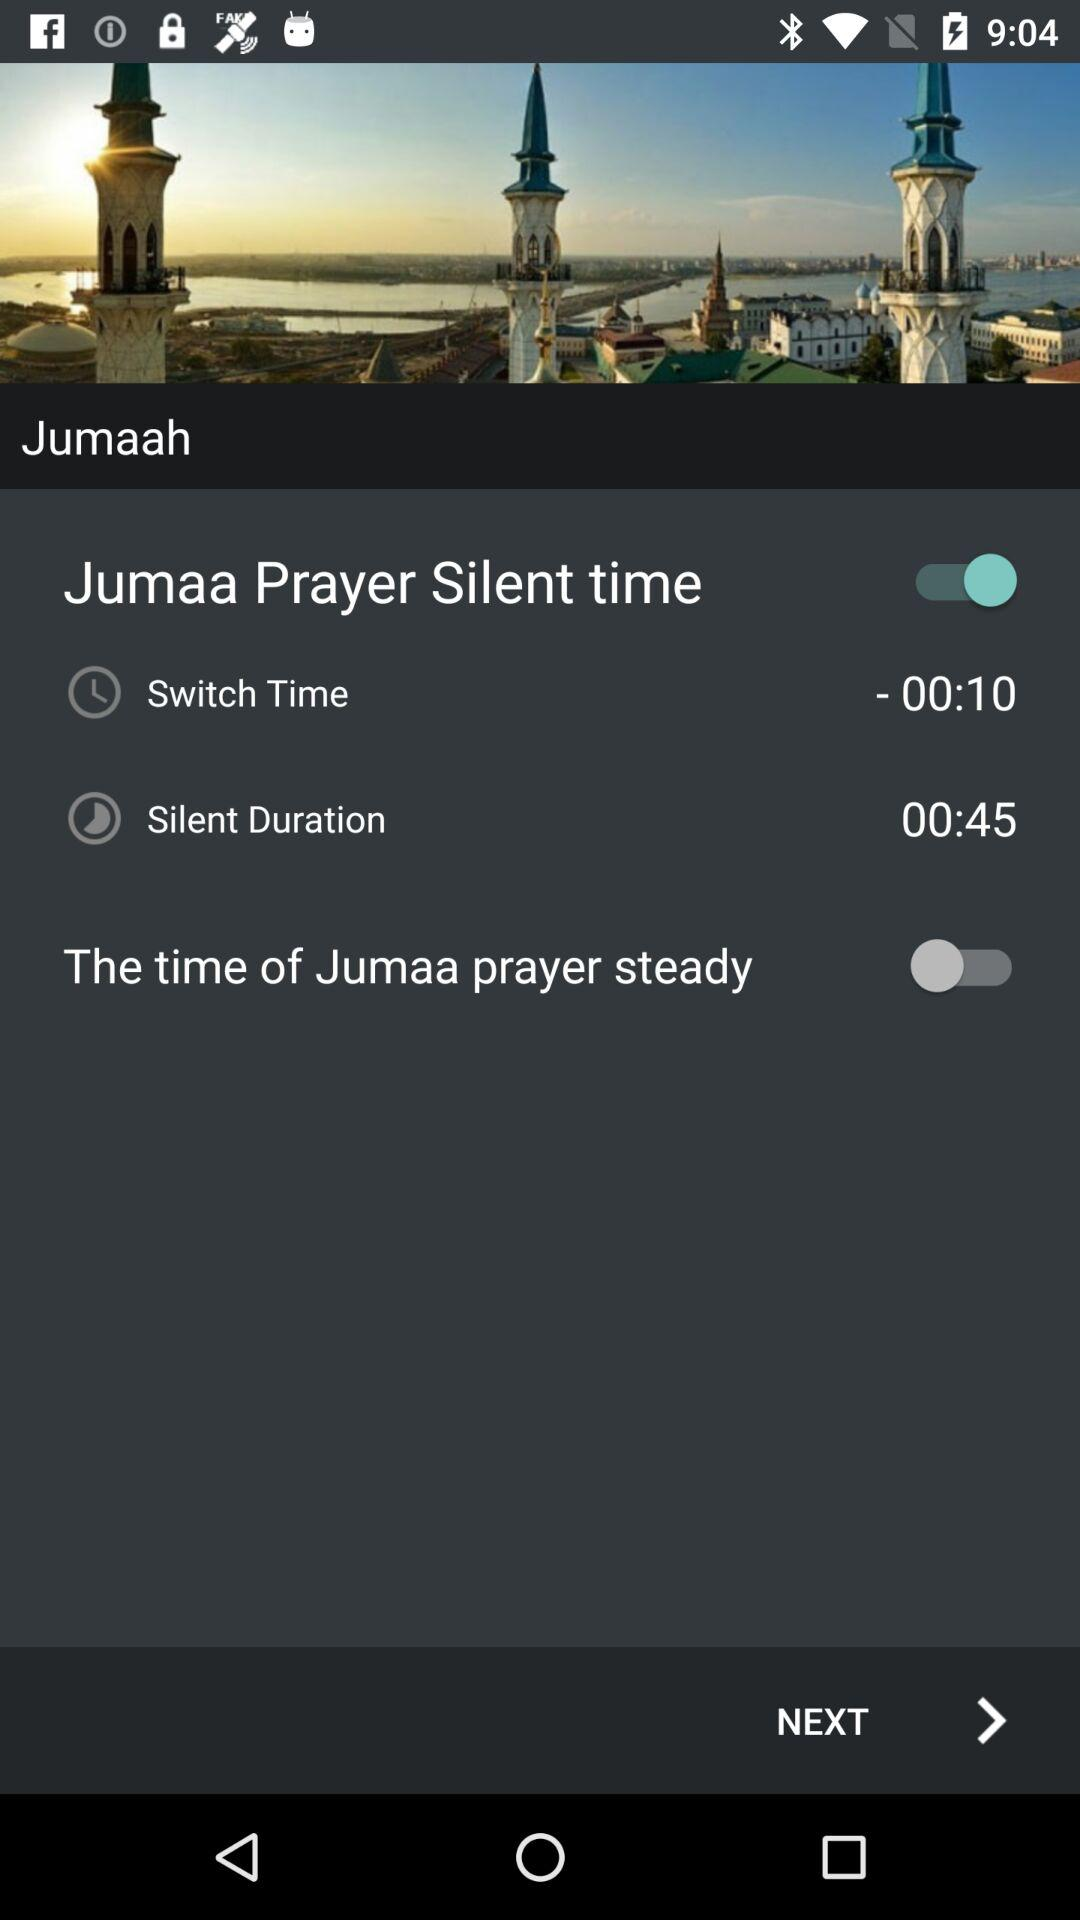What is the silent duration time for Jumaa prayer? The silent duration time is 00:45. 